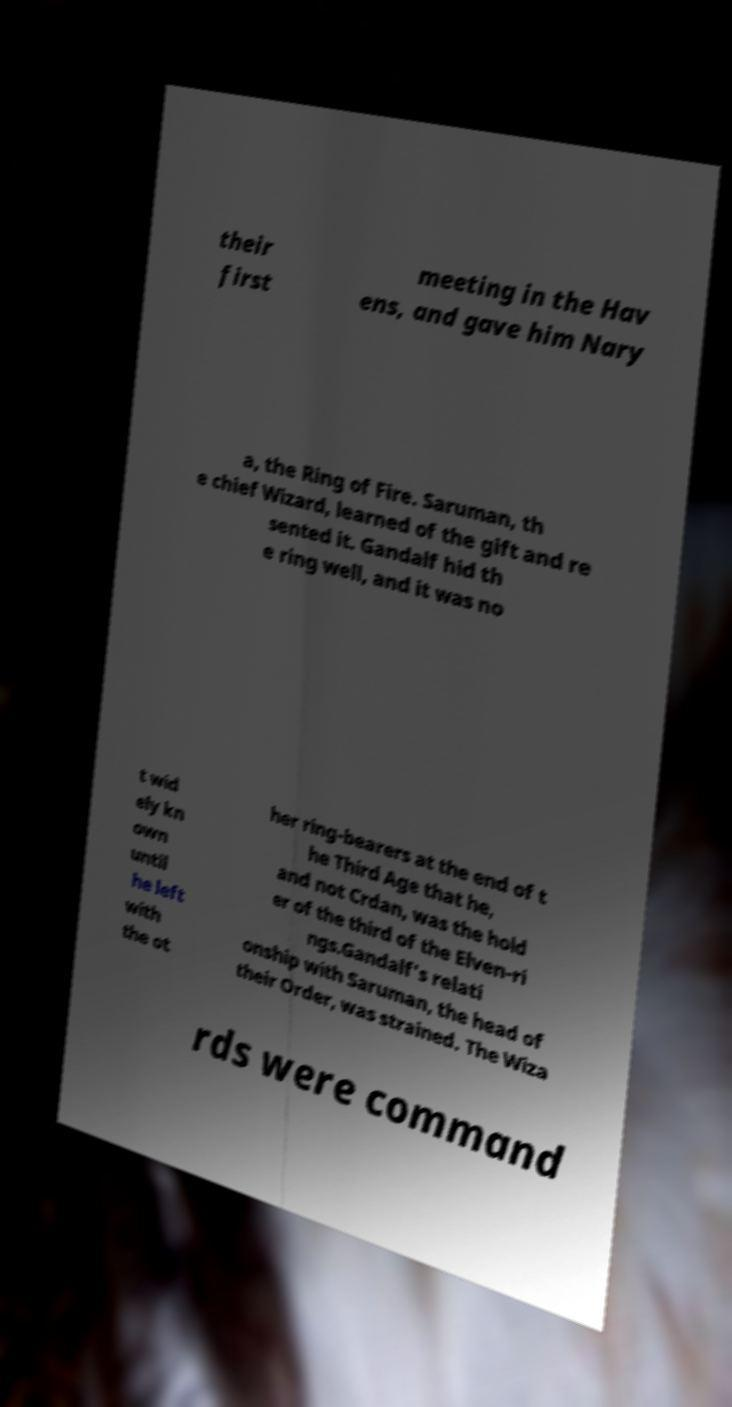Please read and relay the text visible in this image. What does it say? their first meeting in the Hav ens, and gave him Nary a, the Ring of Fire. Saruman, th e chief Wizard, learned of the gift and re sented it. Gandalf hid th e ring well, and it was no t wid ely kn own until he left with the ot her ring-bearers at the end of t he Third Age that he, and not Crdan, was the hold er of the third of the Elven-ri ngs.Gandalf's relati onship with Saruman, the head of their Order, was strained. The Wiza rds were command 